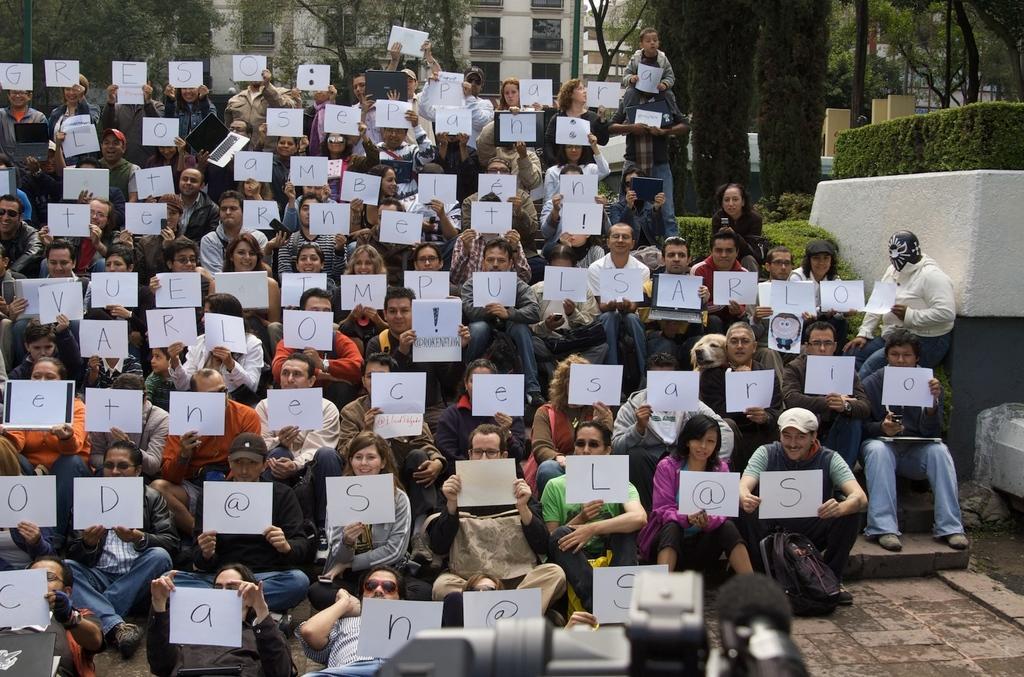Could you give a brief overview of what you see in this image? In the image there are a group of people holding papers in their hands and on each of the paper there are different alphabets and symbols are marked and behind the people there is a building and there are some trees in front of that building. 